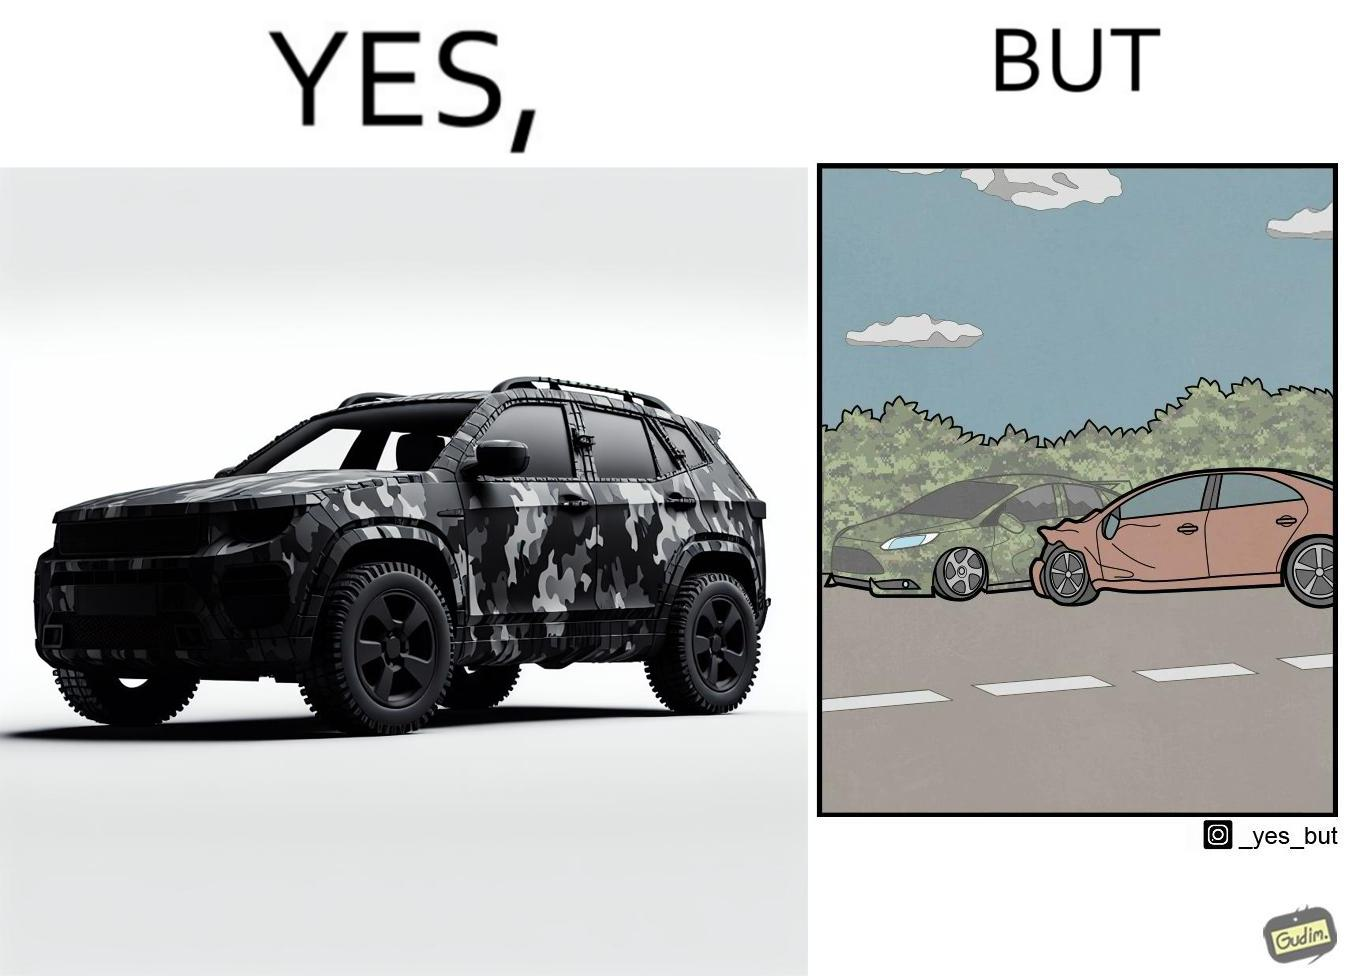What is shown in this image? The image is ironic, because in the left image a car is painted in camouflage color but in the right image the same car is getting involved in accident to due to its color as other drivers face difficulty in recognizing the colors 